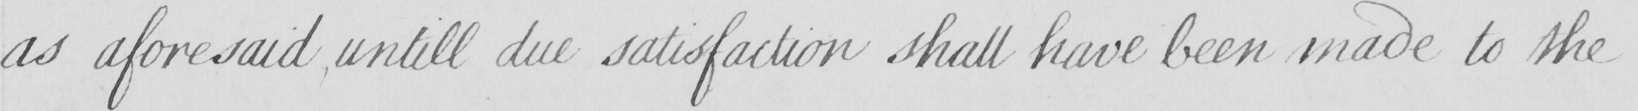Please provide the text content of this handwritten line. as aforesaid , untill due satisfaction shall have been made to the 